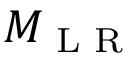<formula> <loc_0><loc_0><loc_500><loc_500>M _ { L R }</formula> 